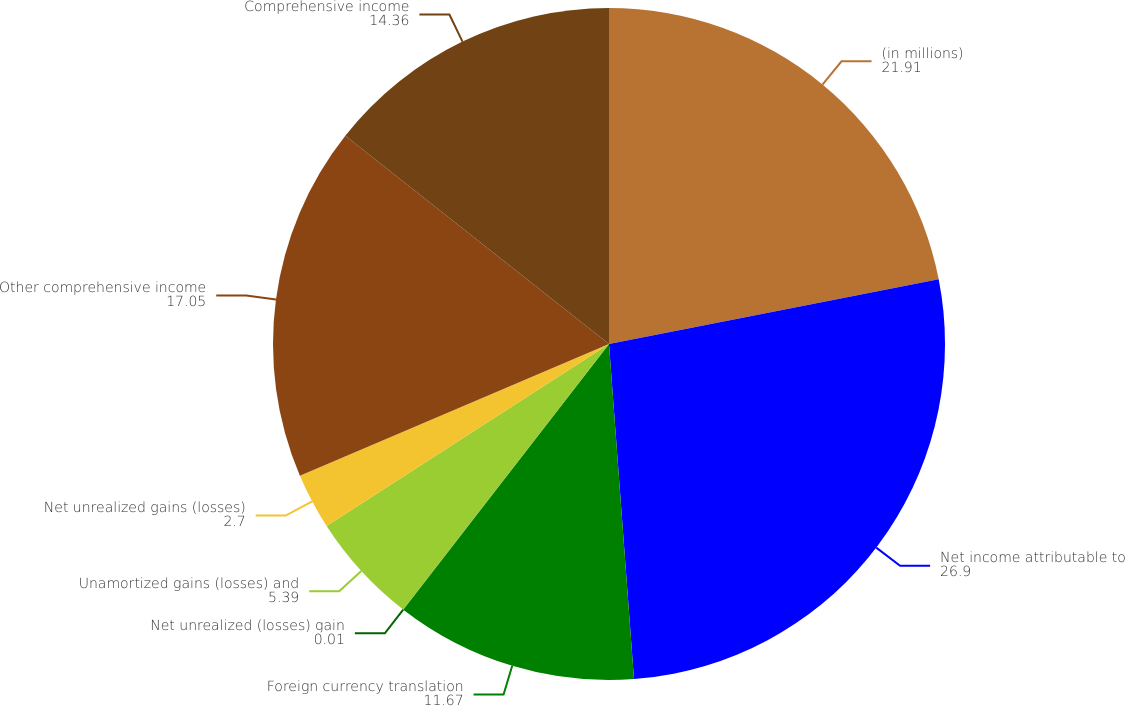Convert chart to OTSL. <chart><loc_0><loc_0><loc_500><loc_500><pie_chart><fcel>(in millions)<fcel>Net income attributable to<fcel>Foreign currency translation<fcel>Net unrealized (losses) gain<fcel>Unamortized gains (losses) and<fcel>Net unrealized gains (losses)<fcel>Other comprehensive income<fcel>Comprehensive income<nl><fcel>21.91%<fcel>26.9%<fcel>11.67%<fcel>0.01%<fcel>5.39%<fcel>2.7%<fcel>17.05%<fcel>14.36%<nl></chart> 